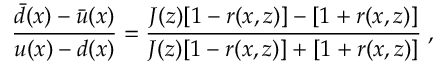Convert formula to latex. <formula><loc_0><loc_0><loc_500><loc_500>\frac { \bar { d } ( x ) - \bar { u } ( x ) } { u ( x ) - d ( x ) } = \frac { J ( z ) [ 1 - r ( x , z ) ] - [ 1 + r ( x , z ) ] } { J ( z ) [ 1 - r ( x , z ) ] + [ 1 + r ( x , z ) ] } \, ,</formula> 